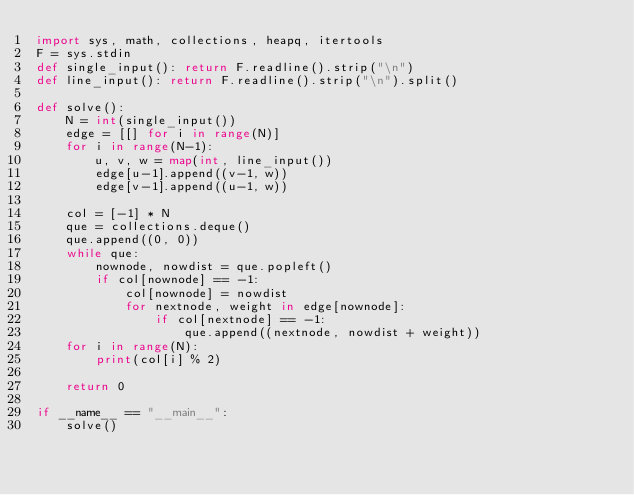Convert code to text. <code><loc_0><loc_0><loc_500><loc_500><_Python_>import sys, math, collections, heapq, itertools
F = sys.stdin
def single_input(): return F.readline().strip("\n")
def line_input(): return F.readline().strip("\n").split()

def solve():
    N = int(single_input())
    edge = [[] for i in range(N)]
    for i in range(N-1):
        u, v, w = map(int, line_input())
        edge[u-1].append((v-1, w))
        edge[v-1].append((u-1, w))
    
    col = [-1] * N
    que = collections.deque()
    que.append((0, 0))
    while que:
        nownode, nowdist = que.popleft()
        if col[nownode] == -1:
            col[nownode] = nowdist
            for nextnode, weight in edge[nownode]:
                if col[nextnode] == -1:
                    que.append((nextnode, nowdist + weight))
    for i in range(N):
        print(col[i] % 2)

    return 0
  
if __name__ == "__main__":
    solve()</code> 